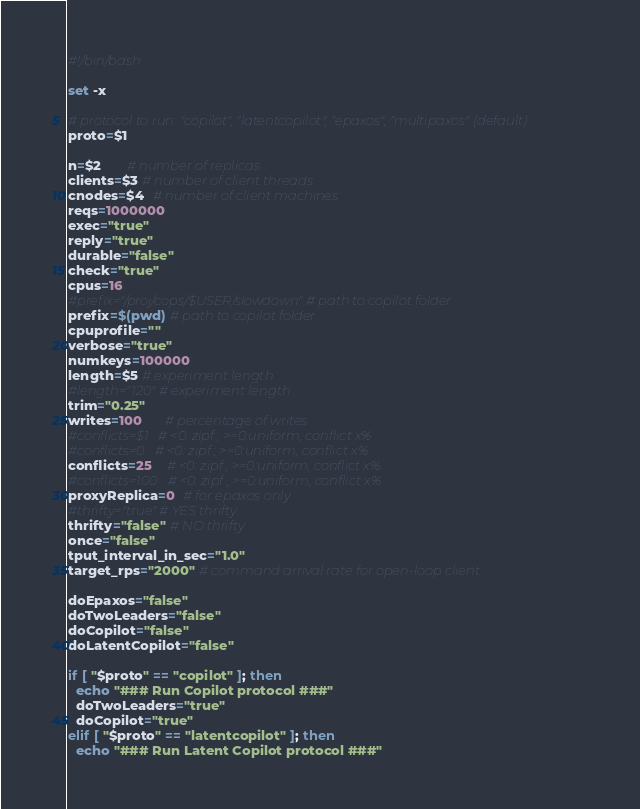<code> <loc_0><loc_0><loc_500><loc_500><_Bash_>#!/bin/bash

set -x

# protocol to run: "copilot", "latentcopilot", "epaxos", "multipaxos" (default)
proto=$1

n=$2       # number of replicas
clients=$3 # number of client threads
cnodes=$4  # number of client machines
reqs=1000000
exec="true"
reply="true"
durable="false"
check="true"
cpus=16
#prefix="/proj/cops/$USER/slowdown" # path to copilot folder
prefix=$(pwd) # path to copilot folder
cpuprofile=""
verbose="true"
numkeys=100000
length=$5 # experiment length
#length="120" # experiment length
trim="0.25"
writes=100      # percentage of writes
#conflicts=$1   # <0: zipf ; >=0:uniform, conflict x%
#conflicts=0   # <0: zipf ; >=0:uniform, conflict x%
conflicts=25    # <0: zipf ; >=0:uniform, conflict x%
#conflicts=100   # <0: zipf ; >=0:uniform, conflict x%
proxyReplica=0  # for epaxos only
#thrifty="true" # YES thrifty
thrifty="false" # NO thrifty
once="false"
tput_interval_in_sec="1.0"
target_rps="2000" # command arrival rate for open-loop client

doEpaxos="false"
doTwoLeaders="false"
doCopilot="false"
doLatentCopilot="false"

if [ "$proto" == "copilot" ]; then
  echo "### Run Copilot protocol ###"
  doTwoLeaders="true"
  doCopilot="true"
elif [ "$proto" == "latentcopilot" ]; then
  echo "### Run Latent Copilot protocol ###"</code> 